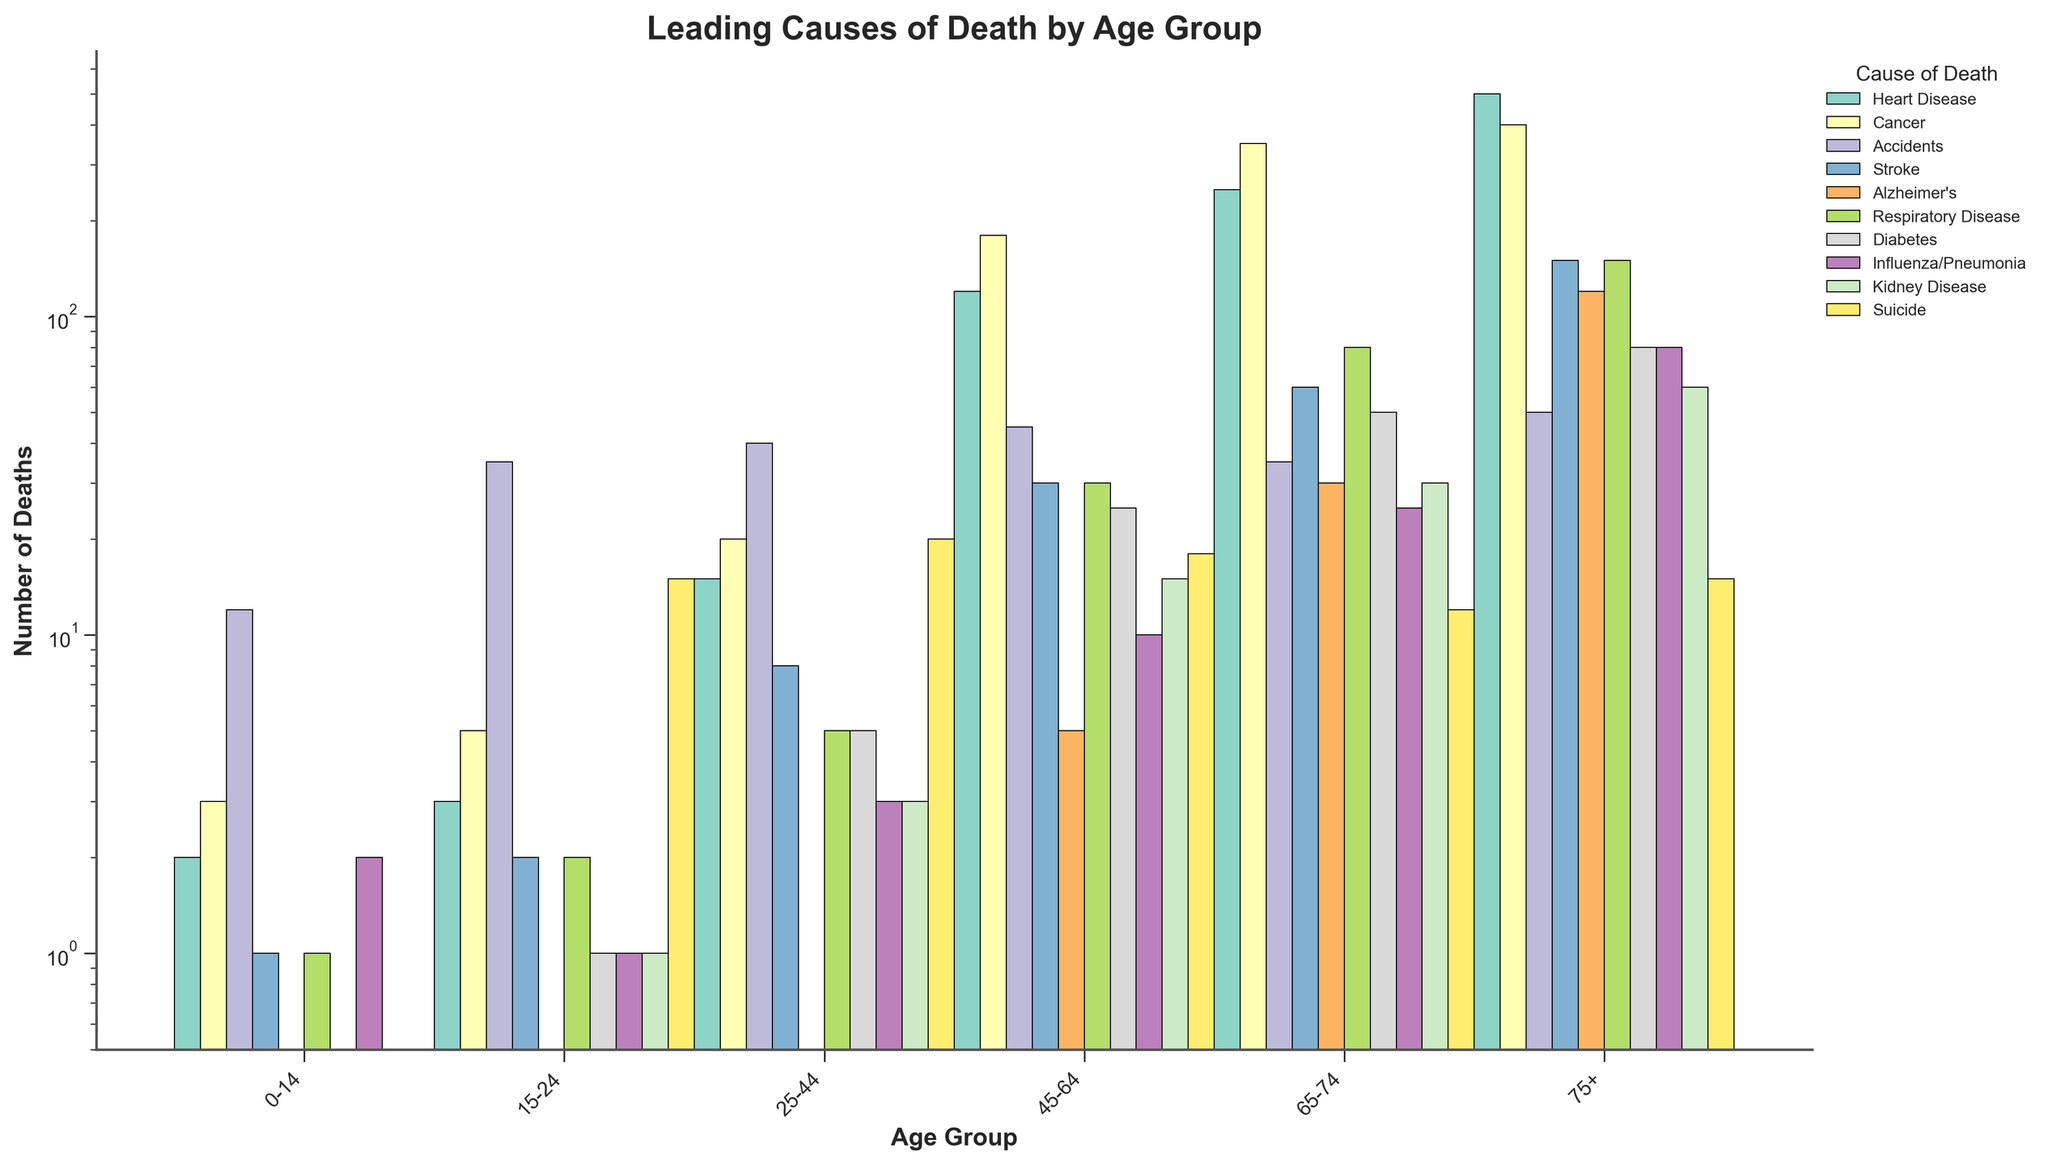What is the leading cause of death for the 25-44 age group? Visually scan the height of the bars for the 25-44 age group. The tallest bar represents "Accidents".
Answer: Accidents Which age group has the highest number of deaths due to Alzheimer's? Look through the height of the Alzheimer's bars across all age groups. The highest bar is in the 75+ age group.
Answer: 75+ How do the total number of deaths from Cancer compare between the 45-64 and 75+ age groups? Sum the height of the Cancer bars for both age groups. The number for 45-64 is 180 and for 75+ is 400. 400 is greater than 180.
Answer: 75+ has more Rank the leading causes of death for the 0-14 age group in descending order. Order the heights of the bars for the 0-14 age group. The ranking from tallest to shortest is Accidents (12), Cancer (3), Heart Disease (2), Influenza/Pneumonia (2), Stroke (1), Respiratory Disease (1).
Answer: Accidents, Cancer, Heart Disease, Influenza/Pneumonia, Stroke, Respiratory Disease Which cause of death has the highest number in the 65-74 age group and what is its number? Look for the tallest bar in the 65-74 age group. The tallest bar corresponds to Cancer with a value of 350.
Answer: Cancer, 350 What is the total number of deaths from Heart Disease across all age groups? Sum the height of the Heart Disease bars for all age groups: 2 + 3 + 15 + 120 + 250 + 500 = 890.
Answer: 890 Are there more deaths from Suicide or Diabetes in the 15-24 age group? Compare the heights of the Suicide and Diabetes bars in the 15-24 age group. The height for Suicide is 15 and for Diabetes is 1.
Answer: Suicide What is the difference in the number of deaths due to Stroke between the 25-44 and 65-74 age groups? Subtract the height of the Stroke bar for the 25-44 age group (8) from the height of the Stroke bar for the 65-74 age group (60). 60 - 8 = 52.
Answer: 52 How many times higher is the number of deaths from Respiratory Disease in the 75+ age group compared to the 0-14 age group? Divide the height of the Respiratory Disease bar for the 75+ age group (150) by the height of the same bar for the 0-14 age group (1). 150 / 1 = 150.
Answer: 150 What is the ratio of deaths from Kidney Disease to Influenza/Pneumonia in the 75+ age group? Divide the height of the Kidney Disease bar (60) by the height of the Influenza/Pneumonia bar (80). 60 / 80 = 0.75.
Answer: 0.75 